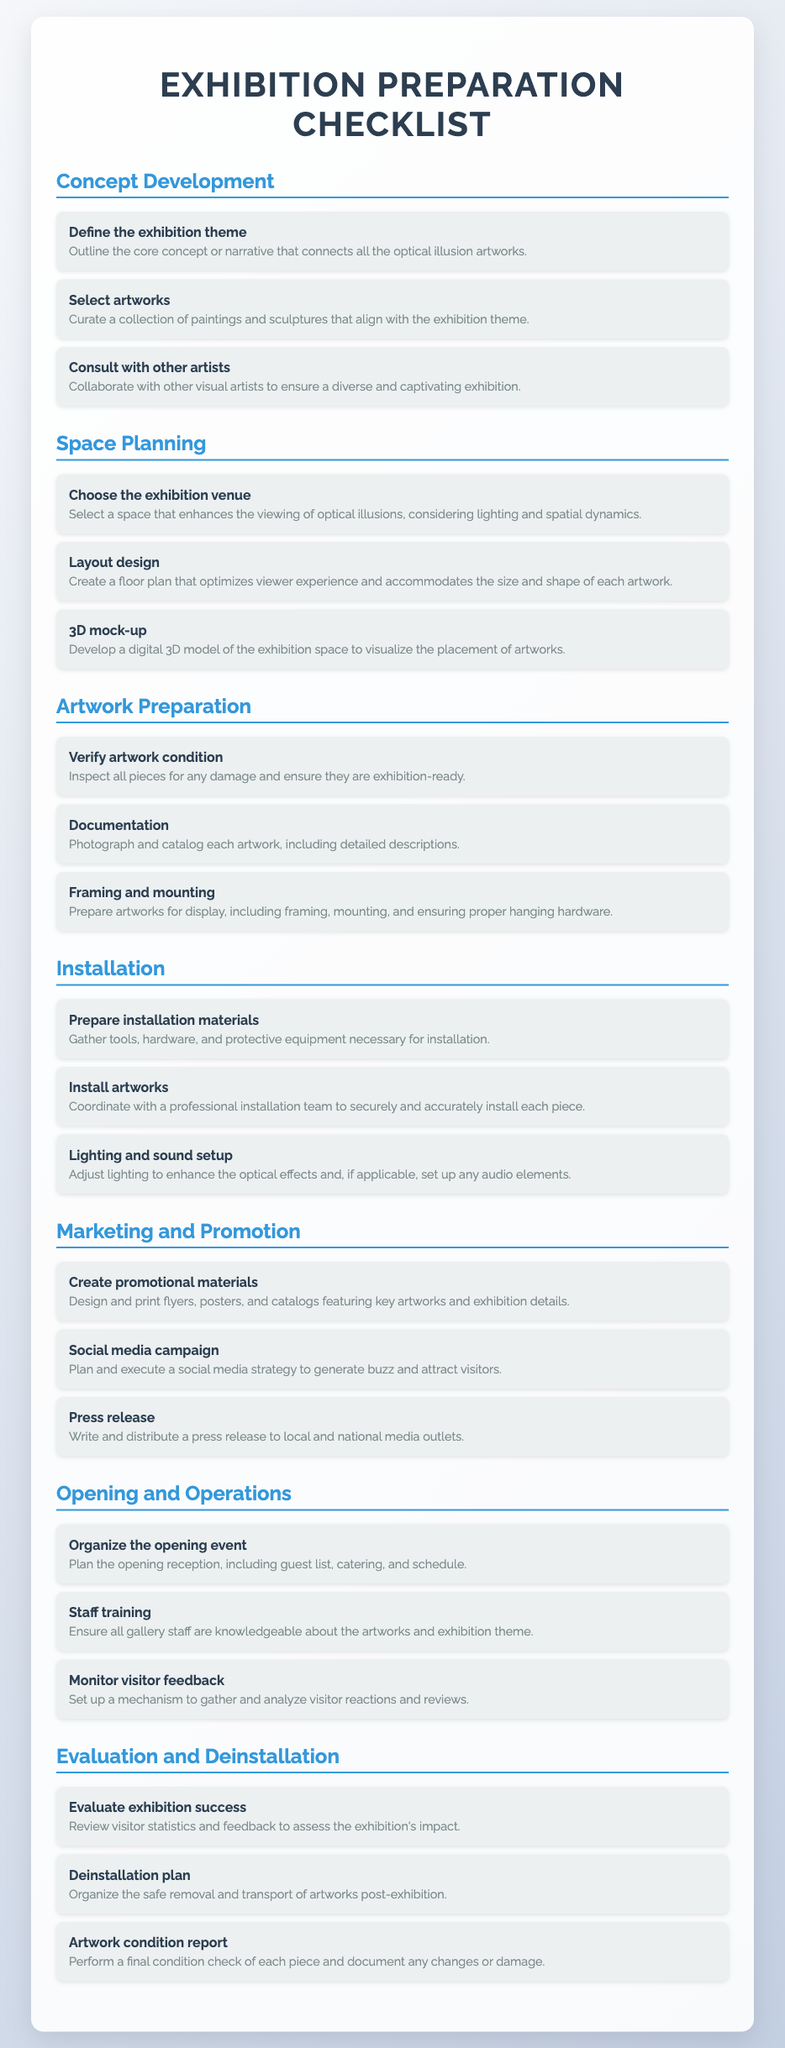what is the first task in the Concept Development section? The first task is to define the exhibition theme, which outlines the core concept or narrative.
Answer: Define the exhibition theme how many tasks are listed under the Installation section? The Installation section contains three distinct tasks that need to be completed.
Answer: 3 which task involves gathering visitor feedback? The task that involves gathering visitor feedback is monitoring visitor feedback, set up to gather and analyze reactions.
Answer: Monitor visitor feedback what is the main focus of the Marketing and Promotion section? The main focus of the Marketing and Promotion section is to create visibility and attract visitors to the exhibition.
Answer: Create visibility and attract visitors what document type does this Checklist represent? This Checklist represents an organized guide for preparing and executing an exhibition of optical illusion artworks.
Answer: Checklist for exhibition preparation what is the purpose of the Deinstallation plan task? The purpose of the Deinstallation plan task is to organize the safe removal and transport of artworks after the exhibition ends.
Answer: Organize the safe removal and transport of artworks how many key milestones are outlined in the document? The document outlines six key sections that represent the major milestones in the exhibition preparation process.
Answer: 6 